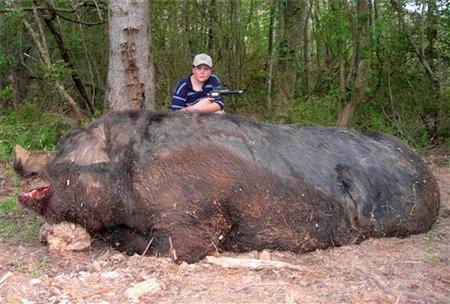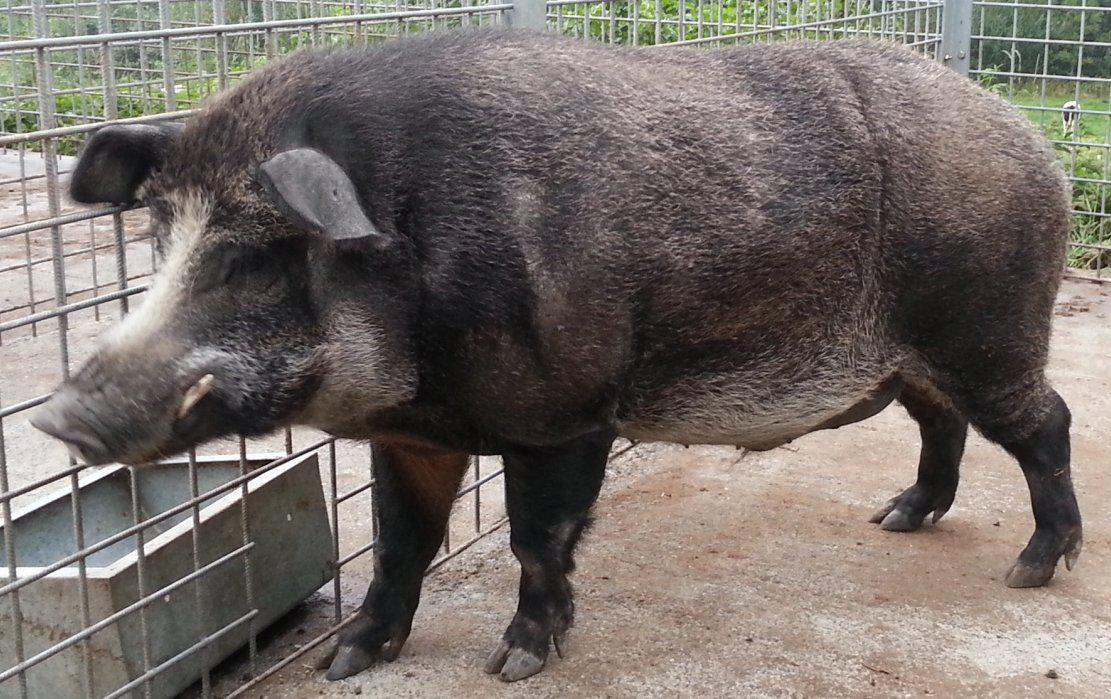The first image is the image on the left, the second image is the image on the right. For the images displayed, is the sentence "In one of the images there is a man posing behind a large boar." factually correct? Answer yes or no. Yes. The first image is the image on the left, the second image is the image on the right. Given the left and right images, does the statement "An image shows a person posed behind a dead boar." hold true? Answer yes or no. Yes. 